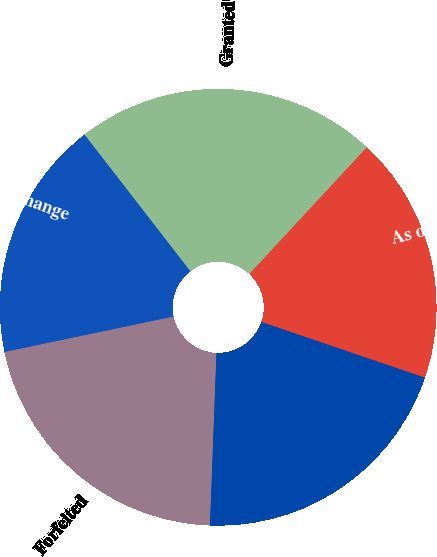<chart> <loc_0><loc_0><loc_500><loc_500><pie_chart><fcel>As of January 1<fcel>Granted<fcel>Performance change<fcel>Forfeited<fcel>As of December 31<nl><fcel>18.32%<fcel>22.39%<fcel>17.8%<fcel>21.11%<fcel>20.37%<nl></chart> 